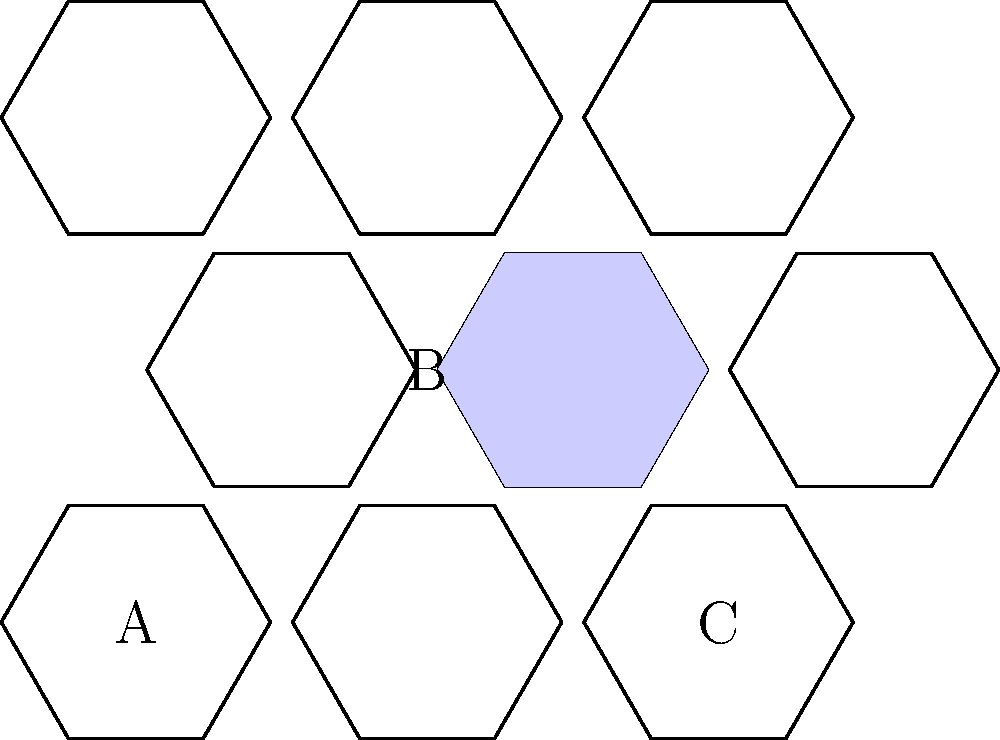In a music recommendation system using a hexagonal grid, each hexagon represents a song, and adjacent hexagons are related songs. If a user starts at song A and wants to reach song C by traversing through related songs, what is the minimum number of songs they need to listen to (including A and C) if they must pass through song B? To solve this problem, we need to understand the structure of the hexagonal grid and count the minimum number of steps required to go from A to C through B. Let's break it down step-by-step:

1. Observe the hexagonal grid structure:
   - Each hexagon represents a song
   - Adjacent hexagons are related songs
   - We need to find the path from A to C that passes through B

2. Count the steps from A to B:
   - A to B is a diagonal move in the hexagonal grid
   - This requires 2 steps (1 step to an adjacent hexagon, then 1 more to B)

3. Count the steps from B to C:
   - B to C is another diagonal move in the opposite direction
   - This also requires 2 steps

4. Calculate the total number of songs in the path:
   - Start at A (count: 1)
   - 2 steps to B (count: 3)
   - 2 steps from B to C (count: 5)
   - End at C (already counted)

5. Verify the path:
   A → (intermediate song) → B → (intermediate song) → C

Therefore, the minimum number of songs the user needs to listen to, including A and C, while passing through B, is 5.
Answer: 5 songs 